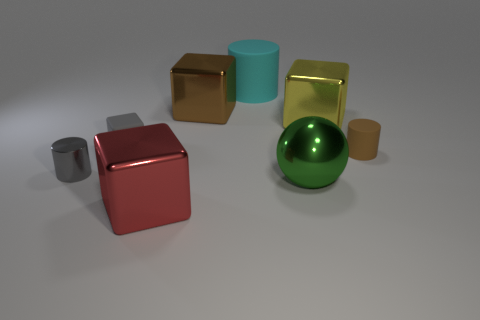What material is the tiny cylinder that is right of the big cube in front of the metal object on the left side of the large red cube made of?
Provide a short and direct response. Rubber. There is a big cyan thing that is the same material as the tiny cube; what shape is it?
Ensure brevity in your answer.  Cylinder. Are there any gray shiny cylinders that are behind the large yellow thing that is behind the green metallic thing?
Offer a very short reply. No. How big is the green metal sphere?
Your response must be concise. Large. How many things are either yellow objects or large brown metallic things?
Your answer should be compact. 2. Do the brown thing that is on the right side of the yellow metallic cube and the large green thing that is to the left of the tiny rubber cylinder have the same material?
Ensure brevity in your answer.  No. There is a small block that is made of the same material as the large cyan cylinder; what is its color?
Your answer should be compact. Gray. What number of brown things have the same size as the brown matte cylinder?
Your response must be concise. 0. How many other things are the same color as the metal ball?
Offer a very short reply. 0. Are there any other things that have the same size as the green shiny object?
Your response must be concise. Yes. 